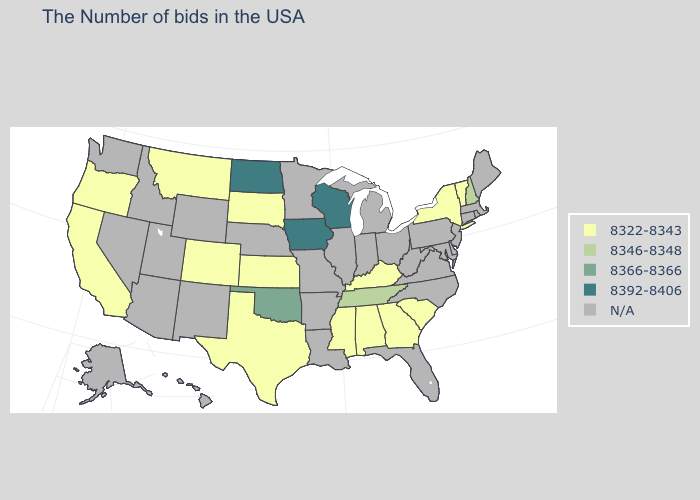Name the states that have a value in the range 8322-8343?
Answer briefly. Vermont, New York, South Carolina, Georgia, Kentucky, Alabama, Mississippi, Kansas, Texas, South Dakota, Colorado, Montana, California, Oregon. What is the value of Georgia?
Quick response, please. 8322-8343. What is the value of Kansas?
Quick response, please. 8322-8343. Which states have the highest value in the USA?
Give a very brief answer. Wisconsin, Iowa, North Dakota. What is the highest value in the USA?
Give a very brief answer. 8392-8406. Which states have the lowest value in the USA?
Quick response, please. Vermont, New York, South Carolina, Georgia, Kentucky, Alabama, Mississippi, Kansas, Texas, South Dakota, Colorado, Montana, California, Oregon. Which states hav the highest value in the West?
Give a very brief answer. Colorado, Montana, California, Oregon. Name the states that have a value in the range 8366-8366?
Answer briefly. Oklahoma. Does the first symbol in the legend represent the smallest category?
Give a very brief answer. Yes. What is the value of Minnesota?
Keep it brief. N/A. Name the states that have a value in the range 8346-8348?
Short answer required. New Hampshire, Tennessee. What is the value of Washington?
Answer briefly. N/A. What is the value of Oregon?
Be succinct. 8322-8343. What is the value of Maryland?
Keep it brief. N/A. 